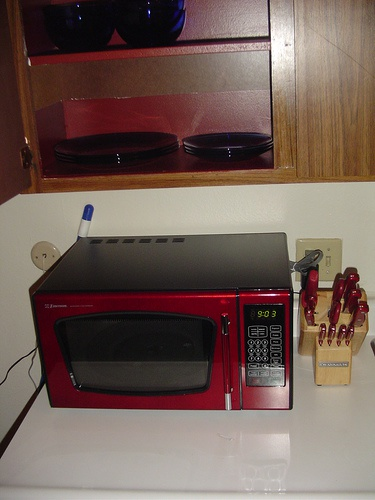Describe the objects in this image and their specific colors. I can see microwave in black, maroon, gray, and darkgray tones, bowl in black, navy, blue, and teal tones, bowl in black, navy, darkblue, and purple tones, knife in black, maroon, and brown tones, and knife in black, maroon, and gray tones in this image. 